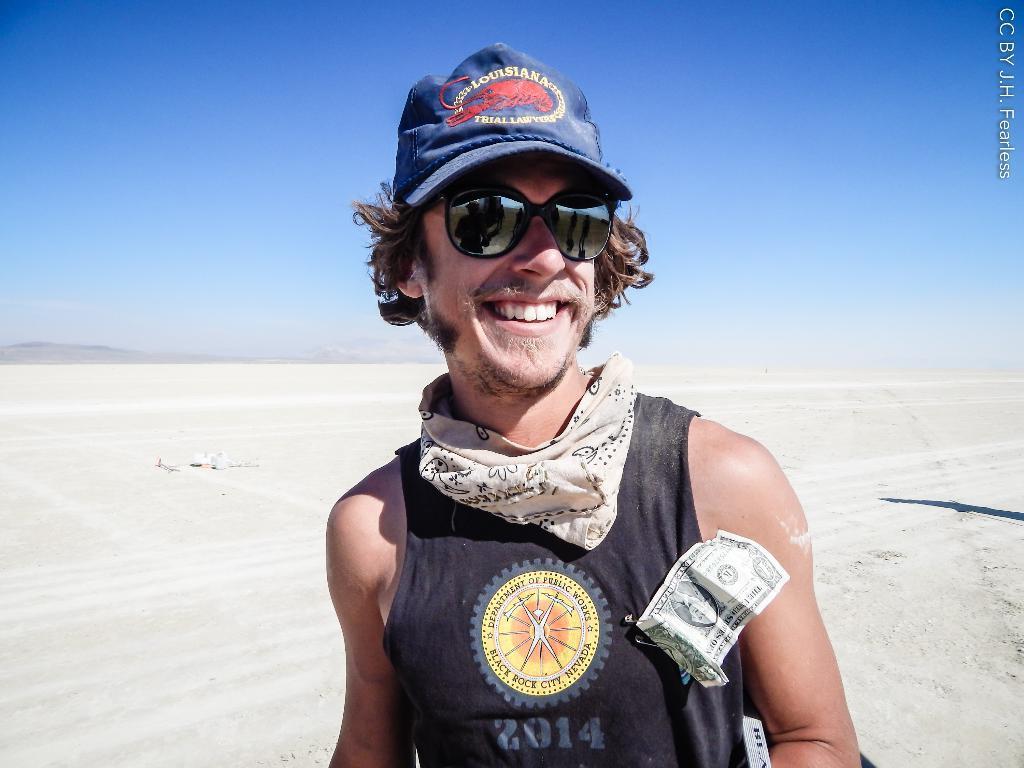In one or two sentences, can you explain what this image depicts? This person wore goggles, cap and smiling. Here we can see currency. Background there is a soul. Sky is in blue color.  This is watermark.  